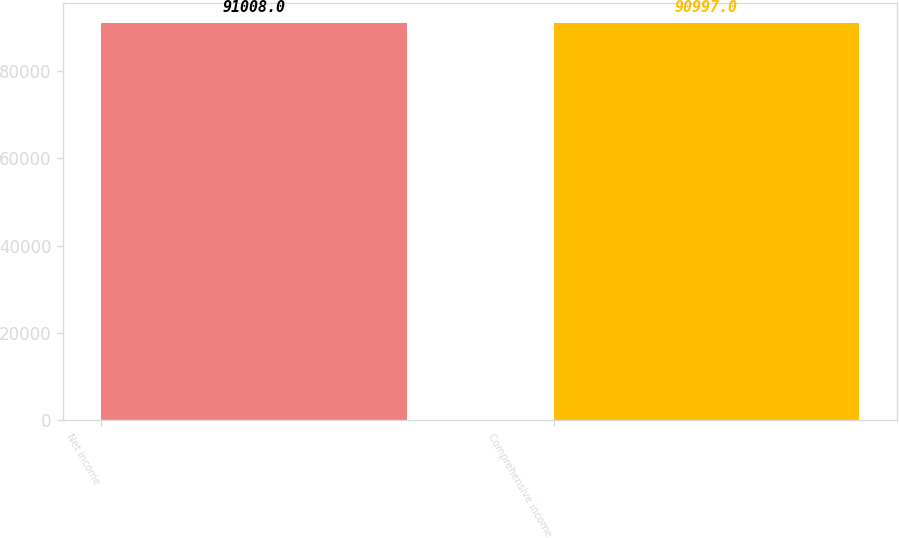Convert chart to OTSL. <chart><loc_0><loc_0><loc_500><loc_500><bar_chart><fcel>Net income<fcel>Comprehensive income<nl><fcel>91008<fcel>90997<nl></chart> 